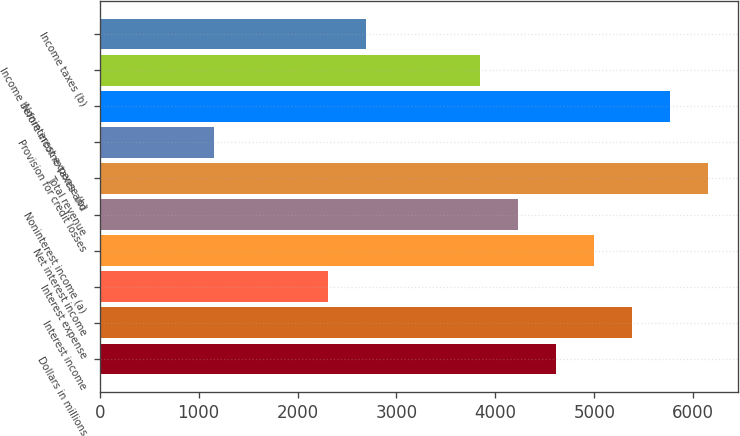Convert chart. <chart><loc_0><loc_0><loc_500><loc_500><bar_chart><fcel>Dollars in millions<fcel>Interest income<fcel>Interest expense<fcel>Net interest income<fcel>Noninterest income (a)<fcel>Total revenue<fcel>Provision for credit losses<fcel>Noninterest expense (b)<fcel>Income before income taxes and<fcel>Income taxes (b)<nl><fcel>4609<fcel>5377<fcel>2305<fcel>4993<fcel>4225<fcel>6145<fcel>1153<fcel>5761<fcel>3841<fcel>2689<nl></chart> 